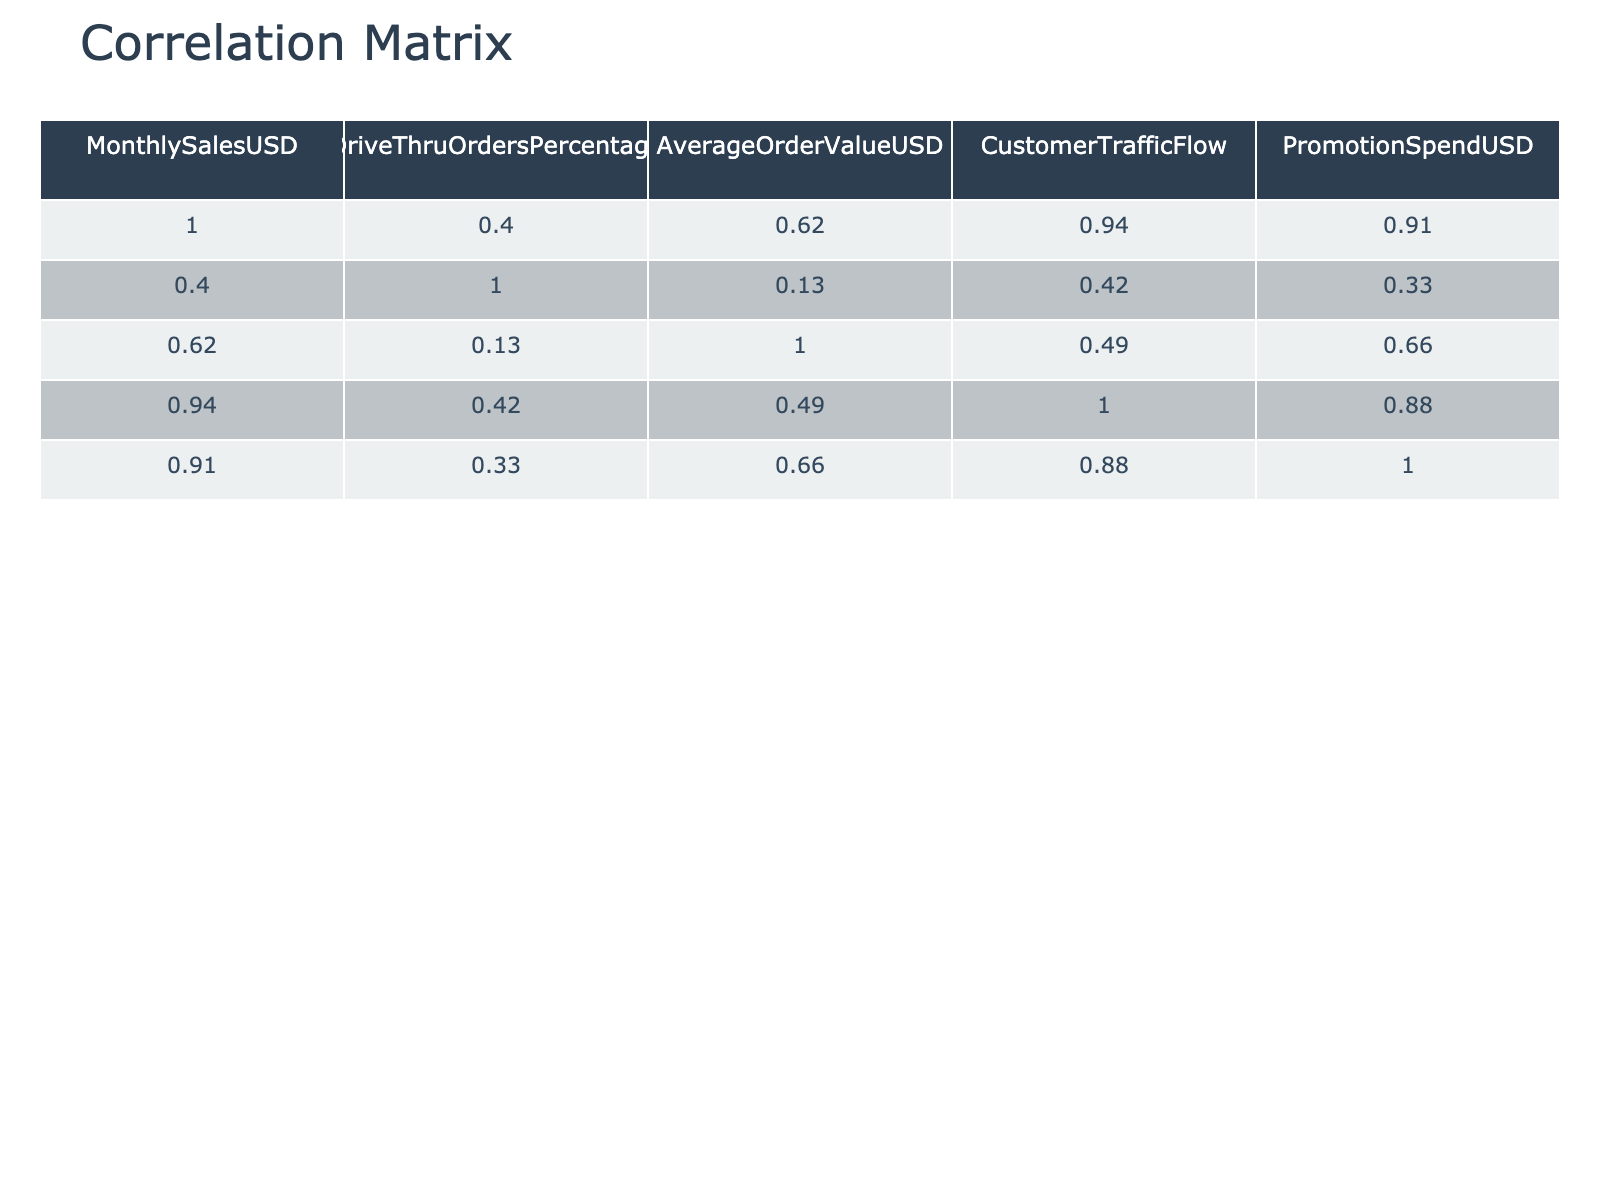What is the Drive-Thru Orders Percentage for Chick-fil-A? The table shows that the Drive-Thru Orders Percentage for Chick-fil-A is listed as 85.
Answer: 85 Which fast food chain has the highest Monthly Sales? According to the table, McDonald's has the highest Monthly Sales at 1,500,000.
Answer: McDonald's What is the average Drive-Thru Orders Percentage across all chains? To find the average Drive-Thru Orders Percentage, sum the percentages (70 + 65 + 75 + 60 + 80 + 85 + 50 + 90 + 40 + 55) =  805, and divide by the number of chains (10), which gives us 805 / 10 = 80.5.
Answer: 80.5 Is the Average Order Value for Taco Bell greater than the Average Order Value for Wendy's? The Average Order Value for Taco Bell is 5.50, while for Wendy's it is 6.50. Therefore, Taco Bell's value is not greater.
Answer: No How does the Monthly Sales of fast food chains correlate with Drive-Thru Orders Percentage, and which chain shows the most significant difference? By analyzing the table, we see that as Drive-Thru Orders Percentage increases, Monthly Sales also tend to be higher. Chick-fil-A shows a high orders percentage (85) and high sales (1,200,000), while Jack in the Box has the lowest sales (450,000) with the lowest percentage (50), indicating a significant difference.
Answer: Chick-fil-A shows the most significant correlation What is the difference in Monthly Sales between KFC and Taco Bell? The Monthly Sales for KFC is 650,000 and for Taco Bell it is 500,000. The difference is calculated by subtracting these two values: 650,000 - 500,000 = 150,000.
Answer: 150,000 Does McDonald's spend more on promotions than Burger King? McDonald's Promotion Spend is 50,000, while Burger King's is 30,000. Therefore, McDonald's does spend more.
Answer: Yes What are the Average Order Values for the top two fast-food chains based on Monthly Sales? The top two chains based on Monthly Sales are McDonald's with 8.50 and Chick-fil-A with 10.00. The average of these two is calculated as (8.50 + 10.00) / 2 = 9.25.
Answer: 9.25 